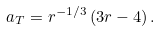<formula> <loc_0><loc_0><loc_500><loc_500>a _ { T } = r ^ { - 1 / 3 } \left ( 3 r - 4 \right ) .</formula> 